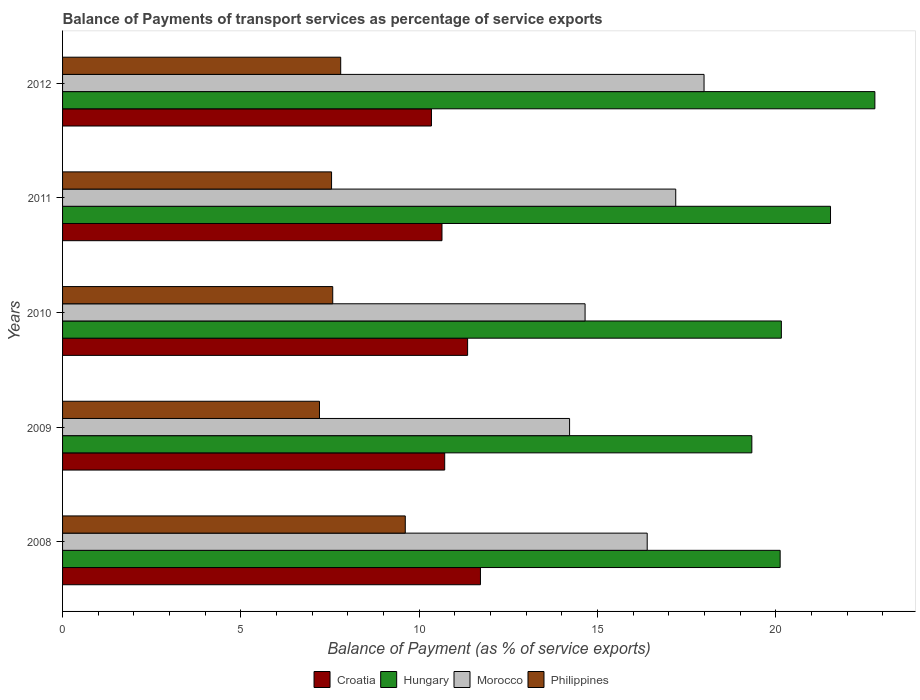Are the number of bars per tick equal to the number of legend labels?
Give a very brief answer. Yes. In how many cases, is the number of bars for a given year not equal to the number of legend labels?
Keep it short and to the point. 0. What is the balance of payments of transport services in Morocco in 2011?
Give a very brief answer. 17.19. Across all years, what is the maximum balance of payments of transport services in Croatia?
Provide a succinct answer. 11.72. Across all years, what is the minimum balance of payments of transport services in Morocco?
Offer a very short reply. 14.22. In which year was the balance of payments of transport services in Morocco minimum?
Keep it short and to the point. 2009. What is the total balance of payments of transport services in Philippines in the graph?
Provide a succinct answer. 39.73. What is the difference between the balance of payments of transport services in Morocco in 2009 and that in 2012?
Provide a short and direct response. -3.77. What is the difference between the balance of payments of transport services in Croatia in 2009 and the balance of payments of transport services in Morocco in 2012?
Make the answer very short. -7.27. What is the average balance of payments of transport services in Morocco per year?
Offer a terse response. 16.09. In the year 2010, what is the difference between the balance of payments of transport services in Hungary and balance of payments of transport services in Philippines?
Keep it short and to the point. 12.58. What is the ratio of the balance of payments of transport services in Hungary in 2009 to that in 2012?
Keep it short and to the point. 0.85. Is the balance of payments of transport services in Philippines in 2010 less than that in 2011?
Your answer should be very brief. No. Is the difference between the balance of payments of transport services in Hungary in 2008 and 2011 greater than the difference between the balance of payments of transport services in Philippines in 2008 and 2011?
Ensure brevity in your answer.  No. What is the difference between the highest and the second highest balance of payments of transport services in Hungary?
Your answer should be compact. 1.24. What is the difference between the highest and the lowest balance of payments of transport services in Croatia?
Provide a short and direct response. 1.37. In how many years, is the balance of payments of transport services in Morocco greater than the average balance of payments of transport services in Morocco taken over all years?
Provide a short and direct response. 3. Is the sum of the balance of payments of transport services in Morocco in 2009 and 2010 greater than the maximum balance of payments of transport services in Hungary across all years?
Your answer should be very brief. Yes. Is it the case that in every year, the sum of the balance of payments of transport services in Hungary and balance of payments of transport services in Croatia is greater than the sum of balance of payments of transport services in Philippines and balance of payments of transport services in Morocco?
Make the answer very short. Yes. What does the 2nd bar from the top in 2012 represents?
Ensure brevity in your answer.  Morocco. How many bars are there?
Your answer should be compact. 20. How many years are there in the graph?
Keep it short and to the point. 5. Does the graph contain any zero values?
Provide a short and direct response. No. Does the graph contain grids?
Provide a short and direct response. No. How many legend labels are there?
Ensure brevity in your answer.  4. How are the legend labels stacked?
Ensure brevity in your answer.  Horizontal. What is the title of the graph?
Offer a very short reply. Balance of Payments of transport services as percentage of service exports. What is the label or title of the X-axis?
Keep it short and to the point. Balance of Payment (as % of service exports). What is the Balance of Payment (as % of service exports) in Croatia in 2008?
Provide a succinct answer. 11.72. What is the Balance of Payment (as % of service exports) in Hungary in 2008?
Your answer should be very brief. 20.12. What is the Balance of Payment (as % of service exports) of Morocco in 2008?
Your response must be concise. 16.39. What is the Balance of Payment (as % of service exports) in Philippines in 2008?
Give a very brief answer. 9.61. What is the Balance of Payment (as % of service exports) of Croatia in 2009?
Provide a short and direct response. 10.71. What is the Balance of Payment (as % of service exports) of Hungary in 2009?
Keep it short and to the point. 19.33. What is the Balance of Payment (as % of service exports) of Morocco in 2009?
Make the answer very short. 14.22. What is the Balance of Payment (as % of service exports) of Philippines in 2009?
Your response must be concise. 7.2. What is the Balance of Payment (as % of service exports) of Croatia in 2010?
Make the answer very short. 11.36. What is the Balance of Payment (as % of service exports) of Hungary in 2010?
Offer a terse response. 20.15. What is the Balance of Payment (as % of service exports) in Morocco in 2010?
Give a very brief answer. 14.65. What is the Balance of Payment (as % of service exports) of Philippines in 2010?
Your answer should be compact. 7.58. What is the Balance of Payment (as % of service exports) of Croatia in 2011?
Your answer should be compact. 10.64. What is the Balance of Payment (as % of service exports) in Hungary in 2011?
Your answer should be very brief. 21.53. What is the Balance of Payment (as % of service exports) of Morocco in 2011?
Make the answer very short. 17.19. What is the Balance of Payment (as % of service exports) in Philippines in 2011?
Make the answer very short. 7.54. What is the Balance of Payment (as % of service exports) in Croatia in 2012?
Make the answer very short. 10.34. What is the Balance of Payment (as % of service exports) of Hungary in 2012?
Keep it short and to the point. 22.78. What is the Balance of Payment (as % of service exports) in Morocco in 2012?
Your answer should be very brief. 17.99. What is the Balance of Payment (as % of service exports) in Philippines in 2012?
Provide a succinct answer. 7.8. Across all years, what is the maximum Balance of Payment (as % of service exports) of Croatia?
Your answer should be compact. 11.72. Across all years, what is the maximum Balance of Payment (as % of service exports) in Hungary?
Your answer should be very brief. 22.78. Across all years, what is the maximum Balance of Payment (as % of service exports) in Morocco?
Your answer should be compact. 17.99. Across all years, what is the maximum Balance of Payment (as % of service exports) of Philippines?
Provide a short and direct response. 9.61. Across all years, what is the minimum Balance of Payment (as % of service exports) of Croatia?
Ensure brevity in your answer.  10.34. Across all years, what is the minimum Balance of Payment (as % of service exports) in Hungary?
Offer a very short reply. 19.33. Across all years, what is the minimum Balance of Payment (as % of service exports) of Morocco?
Your response must be concise. 14.22. Across all years, what is the minimum Balance of Payment (as % of service exports) in Philippines?
Ensure brevity in your answer.  7.2. What is the total Balance of Payment (as % of service exports) in Croatia in the graph?
Make the answer very short. 54.77. What is the total Balance of Payment (as % of service exports) in Hungary in the graph?
Offer a terse response. 103.91. What is the total Balance of Payment (as % of service exports) of Morocco in the graph?
Keep it short and to the point. 80.44. What is the total Balance of Payment (as % of service exports) in Philippines in the graph?
Give a very brief answer. 39.73. What is the difference between the Balance of Payment (as % of service exports) in Croatia in 2008 and that in 2009?
Your answer should be very brief. 1. What is the difference between the Balance of Payment (as % of service exports) in Hungary in 2008 and that in 2009?
Your response must be concise. 0.79. What is the difference between the Balance of Payment (as % of service exports) of Morocco in 2008 and that in 2009?
Make the answer very short. 2.18. What is the difference between the Balance of Payment (as % of service exports) of Philippines in 2008 and that in 2009?
Make the answer very short. 2.41. What is the difference between the Balance of Payment (as % of service exports) of Croatia in 2008 and that in 2010?
Ensure brevity in your answer.  0.36. What is the difference between the Balance of Payment (as % of service exports) in Hungary in 2008 and that in 2010?
Your response must be concise. -0.03. What is the difference between the Balance of Payment (as % of service exports) in Morocco in 2008 and that in 2010?
Ensure brevity in your answer.  1.74. What is the difference between the Balance of Payment (as % of service exports) in Philippines in 2008 and that in 2010?
Provide a succinct answer. 2.03. What is the difference between the Balance of Payment (as % of service exports) of Croatia in 2008 and that in 2011?
Keep it short and to the point. 1.08. What is the difference between the Balance of Payment (as % of service exports) of Hungary in 2008 and that in 2011?
Keep it short and to the point. -1.41. What is the difference between the Balance of Payment (as % of service exports) of Morocco in 2008 and that in 2011?
Give a very brief answer. -0.8. What is the difference between the Balance of Payment (as % of service exports) in Philippines in 2008 and that in 2011?
Ensure brevity in your answer.  2.07. What is the difference between the Balance of Payment (as % of service exports) of Croatia in 2008 and that in 2012?
Your response must be concise. 1.37. What is the difference between the Balance of Payment (as % of service exports) of Hungary in 2008 and that in 2012?
Provide a short and direct response. -2.66. What is the difference between the Balance of Payment (as % of service exports) in Morocco in 2008 and that in 2012?
Give a very brief answer. -1.59. What is the difference between the Balance of Payment (as % of service exports) in Philippines in 2008 and that in 2012?
Provide a succinct answer. 1.81. What is the difference between the Balance of Payment (as % of service exports) of Croatia in 2009 and that in 2010?
Provide a succinct answer. -0.64. What is the difference between the Balance of Payment (as % of service exports) of Hungary in 2009 and that in 2010?
Your answer should be compact. -0.83. What is the difference between the Balance of Payment (as % of service exports) in Morocco in 2009 and that in 2010?
Offer a terse response. -0.43. What is the difference between the Balance of Payment (as % of service exports) in Philippines in 2009 and that in 2010?
Ensure brevity in your answer.  -0.37. What is the difference between the Balance of Payment (as % of service exports) of Croatia in 2009 and that in 2011?
Your answer should be very brief. 0.08. What is the difference between the Balance of Payment (as % of service exports) of Hungary in 2009 and that in 2011?
Make the answer very short. -2.21. What is the difference between the Balance of Payment (as % of service exports) in Morocco in 2009 and that in 2011?
Your answer should be very brief. -2.98. What is the difference between the Balance of Payment (as % of service exports) of Philippines in 2009 and that in 2011?
Your answer should be compact. -0.34. What is the difference between the Balance of Payment (as % of service exports) in Croatia in 2009 and that in 2012?
Your answer should be compact. 0.37. What is the difference between the Balance of Payment (as % of service exports) of Hungary in 2009 and that in 2012?
Make the answer very short. -3.45. What is the difference between the Balance of Payment (as % of service exports) of Morocco in 2009 and that in 2012?
Offer a terse response. -3.77. What is the difference between the Balance of Payment (as % of service exports) in Philippines in 2009 and that in 2012?
Make the answer very short. -0.59. What is the difference between the Balance of Payment (as % of service exports) in Croatia in 2010 and that in 2011?
Your answer should be compact. 0.72. What is the difference between the Balance of Payment (as % of service exports) of Hungary in 2010 and that in 2011?
Your response must be concise. -1.38. What is the difference between the Balance of Payment (as % of service exports) of Morocco in 2010 and that in 2011?
Ensure brevity in your answer.  -2.54. What is the difference between the Balance of Payment (as % of service exports) in Philippines in 2010 and that in 2011?
Your answer should be compact. 0.03. What is the difference between the Balance of Payment (as % of service exports) in Croatia in 2010 and that in 2012?
Ensure brevity in your answer.  1.01. What is the difference between the Balance of Payment (as % of service exports) of Hungary in 2010 and that in 2012?
Your response must be concise. -2.62. What is the difference between the Balance of Payment (as % of service exports) of Morocco in 2010 and that in 2012?
Provide a short and direct response. -3.34. What is the difference between the Balance of Payment (as % of service exports) in Philippines in 2010 and that in 2012?
Offer a very short reply. -0.22. What is the difference between the Balance of Payment (as % of service exports) of Croatia in 2011 and that in 2012?
Provide a succinct answer. 0.3. What is the difference between the Balance of Payment (as % of service exports) in Hungary in 2011 and that in 2012?
Offer a very short reply. -1.24. What is the difference between the Balance of Payment (as % of service exports) of Morocco in 2011 and that in 2012?
Provide a succinct answer. -0.79. What is the difference between the Balance of Payment (as % of service exports) in Philippines in 2011 and that in 2012?
Make the answer very short. -0.26. What is the difference between the Balance of Payment (as % of service exports) in Croatia in 2008 and the Balance of Payment (as % of service exports) in Hungary in 2009?
Offer a very short reply. -7.61. What is the difference between the Balance of Payment (as % of service exports) in Croatia in 2008 and the Balance of Payment (as % of service exports) in Morocco in 2009?
Offer a very short reply. -2.5. What is the difference between the Balance of Payment (as % of service exports) in Croatia in 2008 and the Balance of Payment (as % of service exports) in Philippines in 2009?
Keep it short and to the point. 4.51. What is the difference between the Balance of Payment (as % of service exports) of Hungary in 2008 and the Balance of Payment (as % of service exports) of Morocco in 2009?
Offer a terse response. 5.9. What is the difference between the Balance of Payment (as % of service exports) in Hungary in 2008 and the Balance of Payment (as % of service exports) in Philippines in 2009?
Provide a succinct answer. 12.92. What is the difference between the Balance of Payment (as % of service exports) of Morocco in 2008 and the Balance of Payment (as % of service exports) of Philippines in 2009?
Ensure brevity in your answer.  9.19. What is the difference between the Balance of Payment (as % of service exports) in Croatia in 2008 and the Balance of Payment (as % of service exports) in Hungary in 2010?
Your answer should be compact. -8.44. What is the difference between the Balance of Payment (as % of service exports) in Croatia in 2008 and the Balance of Payment (as % of service exports) in Morocco in 2010?
Give a very brief answer. -2.93. What is the difference between the Balance of Payment (as % of service exports) in Croatia in 2008 and the Balance of Payment (as % of service exports) in Philippines in 2010?
Your answer should be compact. 4.14. What is the difference between the Balance of Payment (as % of service exports) of Hungary in 2008 and the Balance of Payment (as % of service exports) of Morocco in 2010?
Keep it short and to the point. 5.47. What is the difference between the Balance of Payment (as % of service exports) of Hungary in 2008 and the Balance of Payment (as % of service exports) of Philippines in 2010?
Give a very brief answer. 12.54. What is the difference between the Balance of Payment (as % of service exports) of Morocco in 2008 and the Balance of Payment (as % of service exports) of Philippines in 2010?
Your response must be concise. 8.82. What is the difference between the Balance of Payment (as % of service exports) in Croatia in 2008 and the Balance of Payment (as % of service exports) in Hungary in 2011?
Your answer should be compact. -9.82. What is the difference between the Balance of Payment (as % of service exports) in Croatia in 2008 and the Balance of Payment (as % of service exports) in Morocco in 2011?
Keep it short and to the point. -5.48. What is the difference between the Balance of Payment (as % of service exports) in Croatia in 2008 and the Balance of Payment (as % of service exports) in Philippines in 2011?
Make the answer very short. 4.17. What is the difference between the Balance of Payment (as % of service exports) in Hungary in 2008 and the Balance of Payment (as % of service exports) in Morocco in 2011?
Provide a short and direct response. 2.93. What is the difference between the Balance of Payment (as % of service exports) of Hungary in 2008 and the Balance of Payment (as % of service exports) of Philippines in 2011?
Provide a short and direct response. 12.58. What is the difference between the Balance of Payment (as % of service exports) in Morocco in 2008 and the Balance of Payment (as % of service exports) in Philippines in 2011?
Keep it short and to the point. 8.85. What is the difference between the Balance of Payment (as % of service exports) in Croatia in 2008 and the Balance of Payment (as % of service exports) in Hungary in 2012?
Your answer should be compact. -11.06. What is the difference between the Balance of Payment (as % of service exports) of Croatia in 2008 and the Balance of Payment (as % of service exports) of Morocco in 2012?
Offer a terse response. -6.27. What is the difference between the Balance of Payment (as % of service exports) in Croatia in 2008 and the Balance of Payment (as % of service exports) in Philippines in 2012?
Ensure brevity in your answer.  3.92. What is the difference between the Balance of Payment (as % of service exports) of Hungary in 2008 and the Balance of Payment (as % of service exports) of Morocco in 2012?
Offer a very short reply. 2.13. What is the difference between the Balance of Payment (as % of service exports) of Hungary in 2008 and the Balance of Payment (as % of service exports) of Philippines in 2012?
Provide a succinct answer. 12.32. What is the difference between the Balance of Payment (as % of service exports) of Morocco in 2008 and the Balance of Payment (as % of service exports) of Philippines in 2012?
Offer a terse response. 8.59. What is the difference between the Balance of Payment (as % of service exports) of Croatia in 2009 and the Balance of Payment (as % of service exports) of Hungary in 2010?
Make the answer very short. -9.44. What is the difference between the Balance of Payment (as % of service exports) in Croatia in 2009 and the Balance of Payment (as % of service exports) in Morocco in 2010?
Your answer should be very brief. -3.94. What is the difference between the Balance of Payment (as % of service exports) of Croatia in 2009 and the Balance of Payment (as % of service exports) of Philippines in 2010?
Offer a very short reply. 3.14. What is the difference between the Balance of Payment (as % of service exports) in Hungary in 2009 and the Balance of Payment (as % of service exports) in Morocco in 2010?
Your response must be concise. 4.68. What is the difference between the Balance of Payment (as % of service exports) of Hungary in 2009 and the Balance of Payment (as % of service exports) of Philippines in 2010?
Provide a short and direct response. 11.75. What is the difference between the Balance of Payment (as % of service exports) of Morocco in 2009 and the Balance of Payment (as % of service exports) of Philippines in 2010?
Provide a short and direct response. 6.64. What is the difference between the Balance of Payment (as % of service exports) of Croatia in 2009 and the Balance of Payment (as % of service exports) of Hungary in 2011?
Offer a very short reply. -10.82. What is the difference between the Balance of Payment (as % of service exports) of Croatia in 2009 and the Balance of Payment (as % of service exports) of Morocco in 2011?
Offer a very short reply. -6.48. What is the difference between the Balance of Payment (as % of service exports) in Croatia in 2009 and the Balance of Payment (as % of service exports) in Philippines in 2011?
Provide a short and direct response. 3.17. What is the difference between the Balance of Payment (as % of service exports) of Hungary in 2009 and the Balance of Payment (as % of service exports) of Morocco in 2011?
Ensure brevity in your answer.  2.13. What is the difference between the Balance of Payment (as % of service exports) in Hungary in 2009 and the Balance of Payment (as % of service exports) in Philippines in 2011?
Provide a succinct answer. 11.78. What is the difference between the Balance of Payment (as % of service exports) in Morocco in 2009 and the Balance of Payment (as % of service exports) in Philippines in 2011?
Offer a terse response. 6.67. What is the difference between the Balance of Payment (as % of service exports) in Croatia in 2009 and the Balance of Payment (as % of service exports) in Hungary in 2012?
Provide a succinct answer. -12.06. What is the difference between the Balance of Payment (as % of service exports) in Croatia in 2009 and the Balance of Payment (as % of service exports) in Morocco in 2012?
Offer a very short reply. -7.27. What is the difference between the Balance of Payment (as % of service exports) of Croatia in 2009 and the Balance of Payment (as % of service exports) of Philippines in 2012?
Make the answer very short. 2.92. What is the difference between the Balance of Payment (as % of service exports) in Hungary in 2009 and the Balance of Payment (as % of service exports) in Morocco in 2012?
Make the answer very short. 1.34. What is the difference between the Balance of Payment (as % of service exports) of Hungary in 2009 and the Balance of Payment (as % of service exports) of Philippines in 2012?
Offer a terse response. 11.53. What is the difference between the Balance of Payment (as % of service exports) in Morocco in 2009 and the Balance of Payment (as % of service exports) in Philippines in 2012?
Give a very brief answer. 6.42. What is the difference between the Balance of Payment (as % of service exports) in Croatia in 2010 and the Balance of Payment (as % of service exports) in Hungary in 2011?
Keep it short and to the point. -10.18. What is the difference between the Balance of Payment (as % of service exports) of Croatia in 2010 and the Balance of Payment (as % of service exports) of Morocco in 2011?
Offer a terse response. -5.84. What is the difference between the Balance of Payment (as % of service exports) of Croatia in 2010 and the Balance of Payment (as % of service exports) of Philippines in 2011?
Your answer should be compact. 3.81. What is the difference between the Balance of Payment (as % of service exports) in Hungary in 2010 and the Balance of Payment (as % of service exports) in Morocco in 2011?
Give a very brief answer. 2.96. What is the difference between the Balance of Payment (as % of service exports) in Hungary in 2010 and the Balance of Payment (as % of service exports) in Philippines in 2011?
Provide a short and direct response. 12.61. What is the difference between the Balance of Payment (as % of service exports) in Morocco in 2010 and the Balance of Payment (as % of service exports) in Philippines in 2011?
Keep it short and to the point. 7.11. What is the difference between the Balance of Payment (as % of service exports) of Croatia in 2010 and the Balance of Payment (as % of service exports) of Hungary in 2012?
Offer a terse response. -11.42. What is the difference between the Balance of Payment (as % of service exports) of Croatia in 2010 and the Balance of Payment (as % of service exports) of Morocco in 2012?
Provide a succinct answer. -6.63. What is the difference between the Balance of Payment (as % of service exports) of Croatia in 2010 and the Balance of Payment (as % of service exports) of Philippines in 2012?
Your answer should be very brief. 3.56. What is the difference between the Balance of Payment (as % of service exports) of Hungary in 2010 and the Balance of Payment (as % of service exports) of Morocco in 2012?
Your answer should be compact. 2.17. What is the difference between the Balance of Payment (as % of service exports) of Hungary in 2010 and the Balance of Payment (as % of service exports) of Philippines in 2012?
Ensure brevity in your answer.  12.36. What is the difference between the Balance of Payment (as % of service exports) in Morocco in 2010 and the Balance of Payment (as % of service exports) in Philippines in 2012?
Your answer should be compact. 6.85. What is the difference between the Balance of Payment (as % of service exports) in Croatia in 2011 and the Balance of Payment (as % of service exports) in Hungary in 2012?
Offer a very short reply. -12.14. What is the difference between the Balance of Payment (as % of service exports) of Croatia in 2011 and the Balance of Payment (as % of service exports) of Morocco in 2012?
Give a very brief answer. -7.35. What is the difference between the Balance of Payment (as % of service exports) of Croatia in 2011 and the Balance of Payment (as % of service exports) of Philippines in 2012?
Give a very brief answer. 2.84. What is the difference between the Balance of Payment (as % of service exports) in Hungary in 2011 and the Balance of Payment (as % of service exports) in Morocco in 2012?
Ensure brevity in your answer.  3.55. What is the difference between the Balance of Payment (as % of service exports) in Hungary in 2011 and the Balance of Payment (as % of service exports) in Philippines in 2012?
Your response must be concise. 13.73. What is the difference between the Balance of Payment (as % of service exports) of Morocco in 2011 and the Balance of Payment (as % of service exports) of Philippines in 2012?
Offer a terse response. 9.39. What is the average Balance of Payment (as % of service exports) of Croatia per year?
Give a very brief answer. 10.95. What is the average Balance of Payment (as % of service exports) in Hungary per year?
Your answer should be very brief. 20.78. What is the average Balance of Payment (as % of service exports) of Morocco per year?
Your answer should be very brief. 16.09. What is the average Balance of Payment (as % of service exports) of Philippines per year?
Provide a short and direct response. 7.95. In the year 2008, what is the difference between the Balance of Payment (as % of service exports) of Croatia and Balance of Payment (as % of service exports) of Hungary?
Your answer should be very brief. -8.4. In the year 2008, what is the difference between the Balance of Payment (as % of service exports) of Croatia and Balance of Payment (as % of service exports) of Morocco?
Offer a very short reply. -4.68. In the year 2008, what is the difference between the Balance of Payment (as % of service exports) of Croatia and Balance of Payment (as % of service exports) of Philippines?
Keep it short and to the point. 2.11. In the year 2008, what is the difference between the Balance of Payment (as % of service exports) of Hungary and Balance of Payment (as % of service exports) of Morocco?
Your answer should be very brief. 3.73. In the year 2008, what is the difference between the Balance of Payment (as % of service exports) in Hungary and Balance of Payment (as % of service exports) in Philippines?
Keep it short and to the point. 10.51. In the year 2008, what is the difference between the Balance of Payment (as % of service exports) in Morocco and Balance of Payment (as % of service exports) in Philippines?
Offer a terse response. 6.78. In the year 2009, what is the difference between the Balance of Payment (as % of service exports) of Croatia and Balance of Payment (as % of service exports) of Hungary?
Your answer should be very brief. -8.61. In the year 2009, what is the difference between the Balance of Payment (as % of service exports) of Croatia and Balance of Payment (as % of service exports) of Morocco?
Your response must be concise. -3.5. In the year 2009, what is the difference between the Balance of Payment (as % of service exports) of Croatia and Balance of Payment (as % of service exports) of Philippines?
Make the answer very short. 3.51. In the year 2009, what is the difference between the Balance of Payment (as % of service exports) in Hungary and Balance of Payment (as % of service exports) in Morocco?
Provide a short and direct response. 5.11. In the year 2009, what is the difference between the Balance of Payment (as % of service exports) in Hungary and Balance of Payment (as % of service exports) in Philippines?
Ensure brevity in your answer.  12.12. In the year 2009, what is the difference between the Balance of Payment (as % of service exports) in Morocco and Balance of Payment (as % of service exports) in Philippines?
Give a very brief answer. 7.01. In the year 2010, what is the difference between the Balance of Payment (as % of service exports) in Croatia and Balance of Payment (as % of service exports) in Hungary?
Your answer should be compact. -8.8. In the year 2010, what is the difference between the Balance of Payment (as % of service exports) of Croatia and Balance of Payment (as % of service exports) of Morocco?
Keep it short and to the point. -3.29. In the year 2010, what is the difference between the Balance of Payment (as % of service exports) in Croatia and Balance of Payment (as % of service exports) in Philippines?
Your answer should be very brief. 3.78. In the year 2010, what is the difference between the Balance of Payment (as % of service exports) of Hungary and Balance of Payment (as % of service exports) of Morocco?
Keep it short and to the point. 5.5. In the year 2010, what is the difference between the Balance of Payment (as % of service exports) of Hungary and Balance of Payment (as % of service exports) of Philippines?
Your response must be concise. 12.58. In the year 2010, what is the difference between the Balance of Payment (as % of service exports) in Morocco and Balance of Payment (as % of service exports) in Philippines?
Offer a very short reply. 7.08. In the year 2011, what is the difference between the Balance of Payment (as % of service exports) of Croatia and Balance of Payment (as % of service exports) of Hungary?
Your answer should be very brief. -10.89. In the year 2011, what is the difference between the Balance of Payment (as % of service exports) in Croatia and Balance of Payment (as % of service exports) in Morocco?
Give a very brief answer. -6.55. In the year 2011, what is the difference between the Balance of Payment (as % of service exports) of Croatia and Balance of Payment (as % of service exports) of Philippines?
Provide a succinct answer. 3.1. In the year 2011, what is the difference between the Balance of Payment (as % of service exports) in Hungary and Balance of Payment (as % of service exports) in Morocco?
Give a very brief answer. 4.34. In the year 2011, what is the difference between the Balance of Payment (as % of service exports) in Hungary and Balance of Payment (as % of service exports) in Philippines?
Provide a succinct answer. 13.99. In the year 2011, what is the difference between the Balance of Payment (as % of service exports) of Morocco and Balance of Payment (as % of service exports) of Philippines?
Your answer should be very brief. 9.65. In the year 2012, what is the difference between the Balance of Payment (as % of service exports) in Croatia and Balance of Payment (as % of service exports) in Hungary?
Your response must be concise. -12.43. In the year 2012, what is the difference between the Balance of Payment (as % of service exports) of Croatia and Balance of Payment (as % of service exports) of Morocco?
Keep it short and to the point. -7.64. In the year 2012, what is the difference between the Balance of Payment (as % of service exports) in Croatia and Balance of Payment (as % of service exports) in Philippines?
Make the answer very short. 2.54. In the year 2012, what is the difference between the Balance of Payment (as % of service exports) of Hungary and Balance of Payment (as % of service exports) of Morocco?
Make the answer very short. 4.79. In the year 2012, what is the difference between the Balance of Payment (as % of service exports) of Hungary and Balance of Payment (as % of service exports) of Philippines?
Your response must be concise. 14.98. In the year 2012, what is the difference between the Balance of Payment (as % of service exports) of Morocco and Balance of Payment (as % of service exports) of Philippines?
Your answer should be compact. 10.19. What is the ratio of the Balance of Payment (as % of service exports) in Croatia in 2008 to that in 2009?
Ensure brevity in your answer.  1.09. What is the ratio of the Balance of Payment (as % of service exports) of Hungary in 2008 to that in 2009?
Provide a succinct answer. 1.04. What is the ratio of the Balance of Payment (as % of service exports) of Morocco in 2008 to that in 2009?
Provide a short and direct response. 1.15. What is the ratio of the Balance of Payment (as % of service exports) in Philippines in 2008 to that in 2009?
Your answer should be compact. 1.33. What is the ratio of the Balance of Payment (as % of service exports) of Croatia in 2008 to that in 2010?
Offer a very short reply. 1.03. What is the ratio of the Balance of Payment (as % of service exports) of Morocco in 2008 to that in 2010?
Keep it short and to the point. 1.12. What is the ratio of the Balance of Payment (as % of service exports) of Philippines in 2008 to that in 2010?
Provide a short and direct response. 1.27. What is the ratio of the Balance of Payment (as % of service exports) in Croatia in 2008 to that in 2011?
Make the answer very short. 1.1. What is the ratio of the Balance of Payment (as % of service exports) of Hungary in 2008 to that in 2011?
Make the answer very short. 0.93. What is the ratio of the Balance of Payment (as % of service exports) of Morocco in 2008 to that in 2011?
Provide a succinct answer. 0.95. What is the ratio of the Balance of Payment (as % of service exports) in Philippines in 2008 to that in 2011?
Make the answer very short. 1.27. What is the ratio of the Balance of Payment (as % of service exports) in Croatia in 2008 to that in 2012?
Your response must be concise. 1.13. What is the ratio of the Balance of Payment (as % of service exports) in Hungary in 2008 to that in 2012?
Offer a very short reply. 0.88. What is the ratio of the Balance of Payment (as % of service exports) in Morocco in 2008 to that in 2012?
Make the answer very short. 0.91. What is the ratio of the Balance of Payment (as % of service exports) in Philippines in 2008 to that in 2012?
Offer a terse response. 1.23. What is the ratio of the Balance of Payment (as % of service exports) in Croatia in 2009 to that in 2010?
Offer a very short reply. 0.94. What is the ratio of the Balance of Payment (as % of service exports) of Hungary in 2009 to that in 2010?
Ensure brevity in your answer.  0.96. What is the ratio of the Balance of Payment (as % of service exports) in Morocco in 2009 to that in 2010?
Provide a succinct answer. 0.97. What is the ratio of the Balance of Payment (as % of service exports) of Philippines in 2009 to that in 2010?
Your answer should be compact. 0.95. What is the ratio of the Balance of Payment (as % of service exports) in Croatia in 2009 to that in 2011?
Provide a succinct answer. 1.01. What is the ratio of the Balance of Payment (as % of service exports) in Hungary in 2009 to that in 2011?
Offer a very short reply. 0.9. What is the ratio of the Balance of Payment (as % of service exports) of Morocco in 2009 to that in 2011?
Your response must be concise. 0.83. What is the ratio of the Balance of Payment (as % of service exports) in Philippines in 2009 to that in 2011?
Your response must be concise. 0.96. What is the ratio of the Balance of Payment (as % of service exports) of Croatia in 2009 to that in 2012?
Provide a short and direct response. 1.04. What is the ratio of the Balance of Payment (as % of service exports) of Hungary in 2009 to that in 2012?
Offer a very short reply. 0.85. What is the ratio of the Balance of Payment (as % of service exports) of Morocco in 2009 to that in 2012?
Offer a terse response. 0.79. What is the ratio of the Balance of Payment (as % of service exports) of Philippines in 2009 to that in 2012?
Give a very brief answer. 0.92. What is the ratio of the Balance of Payment (as % of service exports) of Croatia in 2010 to that in 2011?
Your answer should be very brief. 1.07. What is the ratio of the Balance of Payment (as % of service exports) in Hungary in 2010 to that in 2011?
Ensure brevity in your answer.  0.94. What is the ratio of the Balance of Payment (as % of service exports) of Morocco in 2010 to that in 2011?
Ensure brevity in your answer.  0.85. What is the ratio of the Balance of Payment (as % of service exports) in Croatia in 2010 to that in 2012?
Offer a terse response. 1.1. What is the ratio of the Balance of Payment (as % of service exports) in Hungary in 2010 to that in 2012?
Offer a terse response. 0.88. What is the ratio of the Balance of Payment (as % of service exports) in Morocco in 2010 to that in 2012?
Offer a terse response. 0.81. What is the ratio of the Balance of Payment (as % of service exports) of Philippines in 2010 to that in 2012?
Provide a succinct answer. 0.97. What is the ratio of the Balance of Payment (as % of service exports) of Croatia in 2011 to that in 2012?
Make the answer very short. 1.03. What is the ratio of the Balance of Payment (as % of service exports) of Hungary in 2011 to that in 2012?
Your response must be concise. 0.95. What is the ratio of the Balance of Payment (as % of service exports) of Morocco in 2011 to that in 2012?
Your answer should be compact. 0.96. What is the ratio of the Balance of Payment (as % of service exports) in Philippines in 2011 to that in 2012?
Offer a very short reply. 0.97. What is the difference between the highest and the second highest Balance of Payment (as % of service exports) of Croatia?
Provide a succinct answer. 0.36. What is the difference between the highest and the second highest Balance of Payment (as % of service exports) of Hungary?
Your response must be concise. 1.24. What is the difference between the highest and the second highest Balance of Payment (as % of service exports) of Morocco?
Give a very brief answer. 0.79. What is the difference between the highest and the second highest Balance of Payment (as % of service exports) of Philippines?
Make the answer very short. 1.81. What is the difference between the highest and the lowest Balance of Payment (as % of service exports) of Croatia?
Your response must be concise. 1.37. What is the difference between the highest and the lowest Balance of Payment (as % of service exports) in Hungary?
Your response must be concise. 3.45. What is the difference between the highest and the lowest Balance of Payment (as % of service exports) in Morocco?
Your answer should be very brief. 3.77. What is the difference between the highest and the lowest Balance of Payment (as % of service exports) of Philippines?
Ensure brevity in your answer.  2.41. 